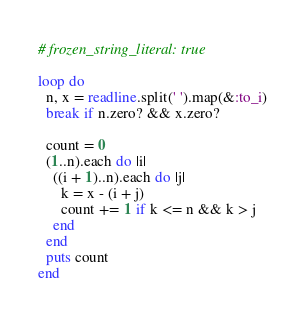Convert code to text. <code><loc_0><loc_0><loc_500><loc_500><_Ruby_># frozen_string_literal: true

loop do
  n, x = readline.split(' ').map(&:to_i)
  break if n.zero? && x.zero?

  count = 0
  (1..n).each do |i|
    ((i + 1)..n).each do |j|
      k = x - (i + j)
      count += 1 if k <= n && k > j
    end
  end
  puts count
end

</code> 